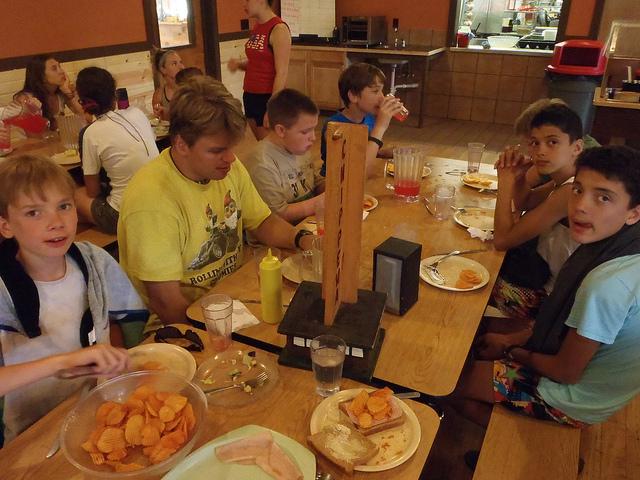Is this camp for kids?
Answer briefly. Yes. How many plates are there?
Quick response, please. 9. How many people were sitting at  the table?
Be succinct. 7. Is this in a fast food restaurant?
Answer briefly. No. Is there napkins in the napkin holder?
Short answer required. No. 